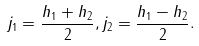Convert formula to latex. <formula><loc_0><loc_0><loc_500><loc_500>j _ { 1 } = \frac { h _ { 1 } + h _ { 2 } } { 2 } , j _ { 2 } = \frac { h _ { 1 } - h _ { 2 } } { 2 } .</formula> 